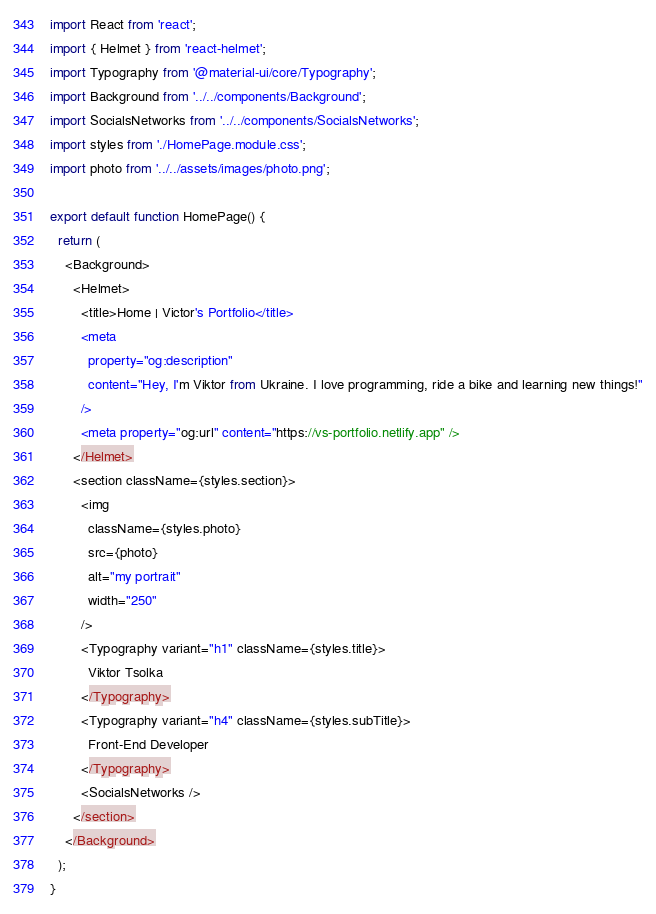Convert code to text. <code><loc_0><loc_0><loc_500><loc_500><_JavaScript_>import React from 'react';
import { Helmet } from 'react-helmet';
import Typography from '@material-ui/core/Typography';
import Background from '../../components/Background';
import SocialsNetworks from '../../components/SocialsNetworks';
import styles from './HomePage.module.css';
import photo from '../../assets/images/photo.png';

export default function HomePage() {
  return (
    <Background>
      <Helmet>
        <title>Home | Victor's Portfolio</title>
        <meta
          property="og:description"
          content="Hey, I'm Viktor from Ukraine. I love programming, ride a bike and learning new things!"
        />
        <meta property="og:url" content="https://vs-portfolio.netlify.app" />
      </Helmet>
      <section className={styles.section}>
        <img
          className={styles.photo}
          src={photo}
          alt="my portrait"
          width="250"
        />
        <Typography variant="h1" className={styles.title}>
          Viktor Tsolka
        </Typography>
        <Typography variant="h4" className={styles.subTitle}>
          Front-End Developer
        </Typography>
        <SocialsNetworks />
      </section>
    </Background>
  );
}
</code> 